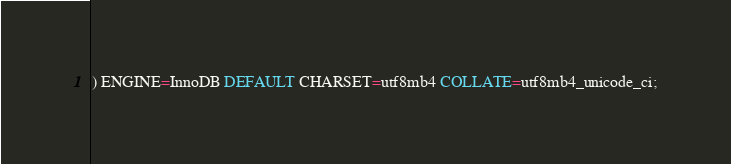<code> <loc_0><loc_0><loc_500><loc_500><_SQL_>) ENGINE=InnoDB DEFAULT CHARSET=utf8mb4 COLLATE=utf8mb4_unicode_ci;
</code> 